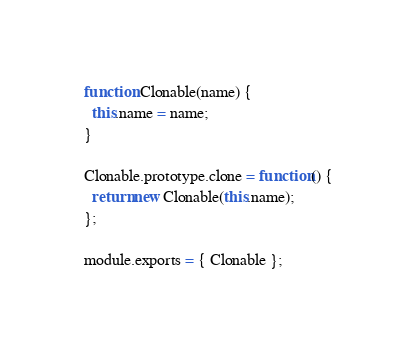Convert code to text. <code><loc_0><loc_0><loc_500><loc_500><_JavaScript_>function Clonable(name) {
  this.name = name;
}

Clonable.prototype.clone = function() {
  return new Clonable(this.name);
};

module.exports = { Clonable };
</code> 